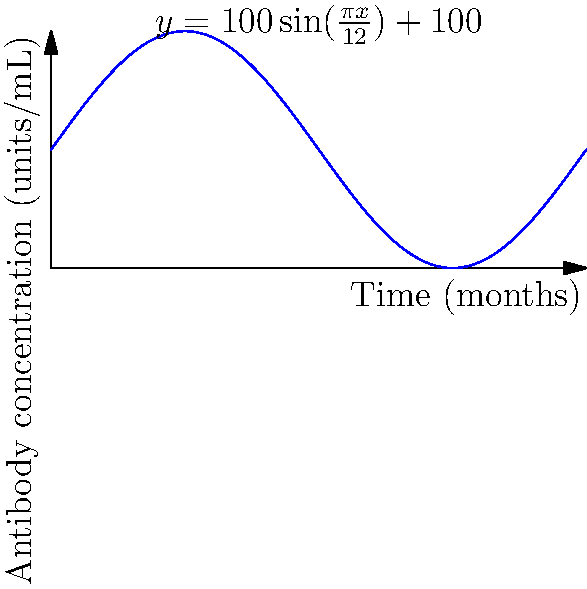The concentration of a specific antibody in a patient's bloodstream after receiving a novel immunotherapy treatment can be modeled by the function $y = 100\sin(\frac{\pi x}{12})+100$, where $y$ represents the antibody concentration in units/mL and $x$ represents time in months. At what time point (in months) does the antibody concentration reach its maximum value for the first time? To find the maximum value of the antibody concentration, we need to determine when the sine function reaches its peak within the first cycle.

1) The general form of a sine function is $y = A\sin(Bx) + C$, where:
   $A$ is the amplitude
   $B$ is the angular frequency
   $C$ is the vertical shift

2) In our function $y = 100\sin(\frac{\pi x}{12})+100$:
   $A = 100$
   $B = \frac{\pi}{12}$
   $C = 100$

3) The sine function reaches its maximum value when the angle inside is $\frac{\pi}{2}$ or 90 degrees.

4) So, we need to solve: $\frac{\pi x}{12} = \frac{\pi}{2}$

5) Multiply both sides by $\frac{12}{\pi}$:
   $x = \frac{12}{\pi} \cdot \frac{\pi}{2} = 6$

6) Therefore, the antibody concentration reaches its maximum value for the first time at 6 months.
Answer: 6 months 